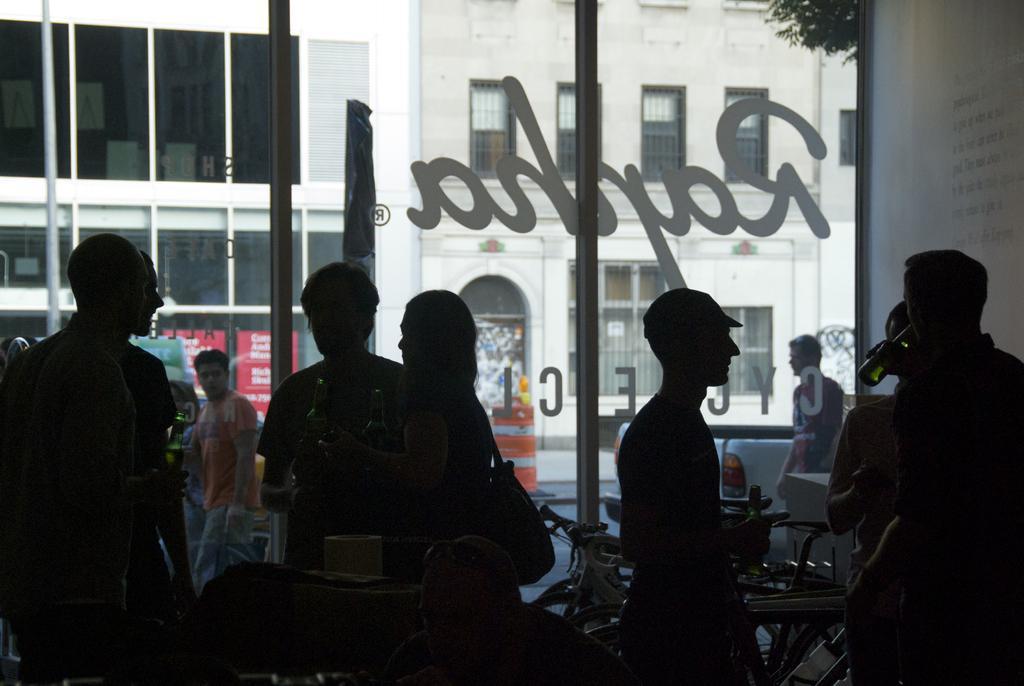Describe this image in one or two sentences. In this image, we can see a group of people. In the background, we can see a glass door, outside the glass door, we can see a man walking, building, window, plant. 